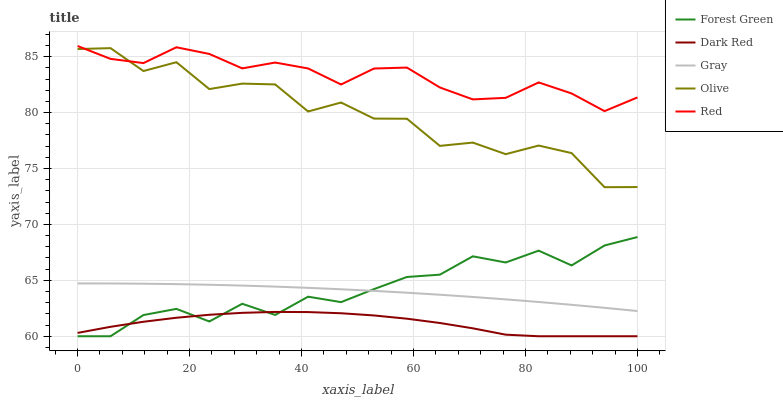Does Dark Red have the minimum area under the curve?
Answer yes or no. Yes. Does Red have the maximum area under the curve?
Answer yes or no. Yes. Does Forest Green have the minimum area under the curve?
Answer yes or no. No. Does Forest Green have the maximum area under the curve?
Answer yes or no. No. Is Gray the smoothest?
Answer yes or no. Yes. Is Olive the roughest?
Answer yes or no. Yes. Is Dark Red the smoothest?
Answer yes or no. No. Is Dark Red the roughest?
Answer yes or no. No. Does Red have the lowest value?
Answer yes or no. No. Does Forest Green have the highest value?
Answer yes or no. No. Is Gray less than Olive?
Answer yes or no. Yes. Is Red greater than Forest Green?
Answer yes or no. Yes. Does Gray intersect Olive?
Answer yes or no. No. 